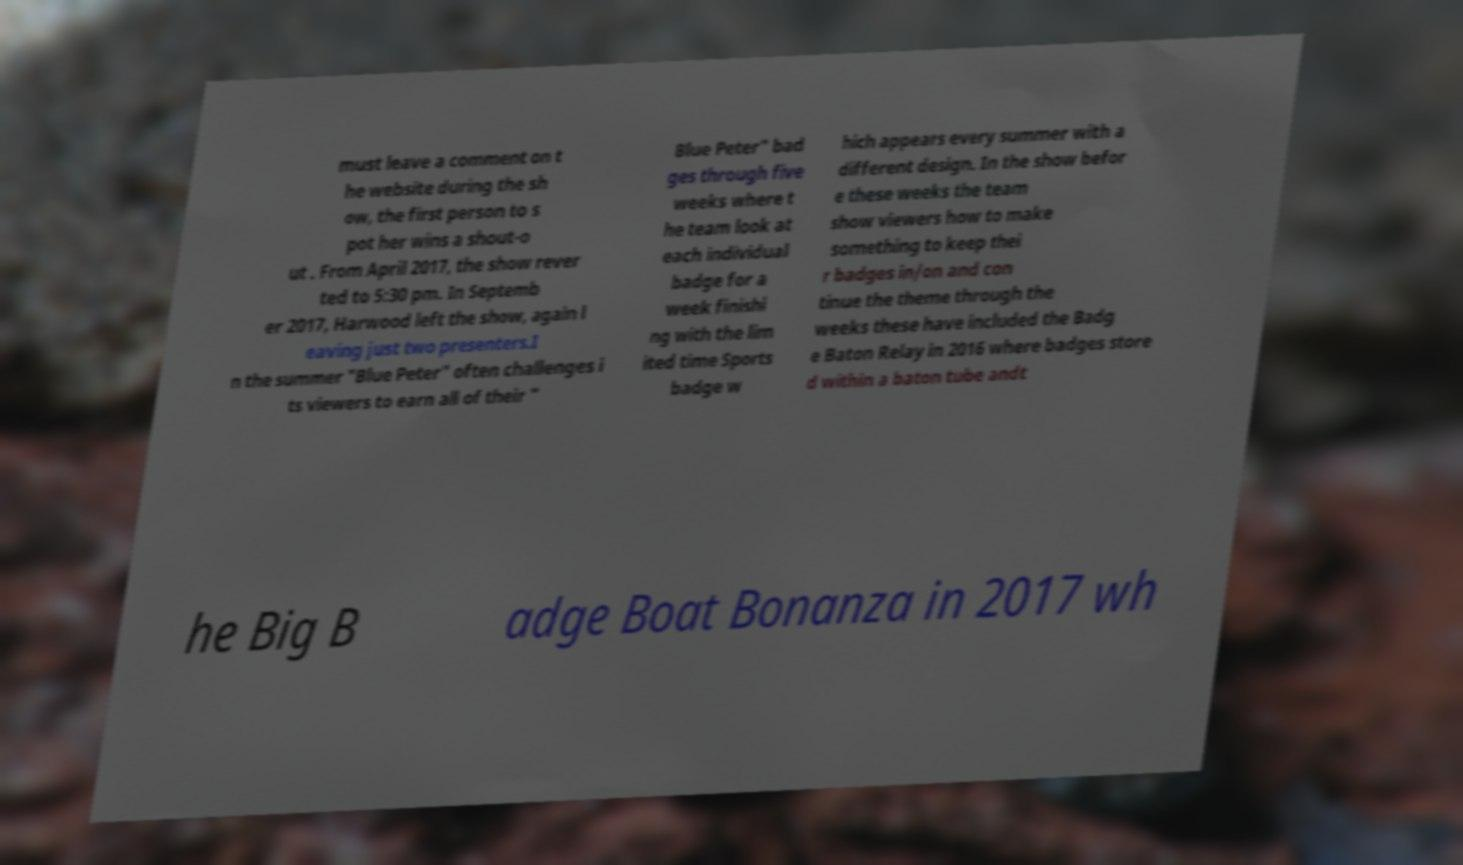Could you extract and type out the text from this image? must leave a comment on t he website during the sh ow, the first person to s pot her wins a shout-o ut . From April 2017, the show rever ted to 5:30 pm. In Septemb er 2017, Harwood left the show, again l eaving just two presenters.I n the summer "Blue Peter" often challenges i ts viewers to earn all of their " Blue Peter" bad ges through five weeks where t he team look at each individual badge for a week finishi ng with the lim ited time Sports badge w hich appears every summer with a different design. In the show befor e these weeks the team show viewers how to make something to keep thei r badges in/on and con tinue the theme through the weeks these have included the Badg e Baton Relay in 2016 where badges store d within a baton tube andt he Big B adge Boat Bonanza in 2017 wh 